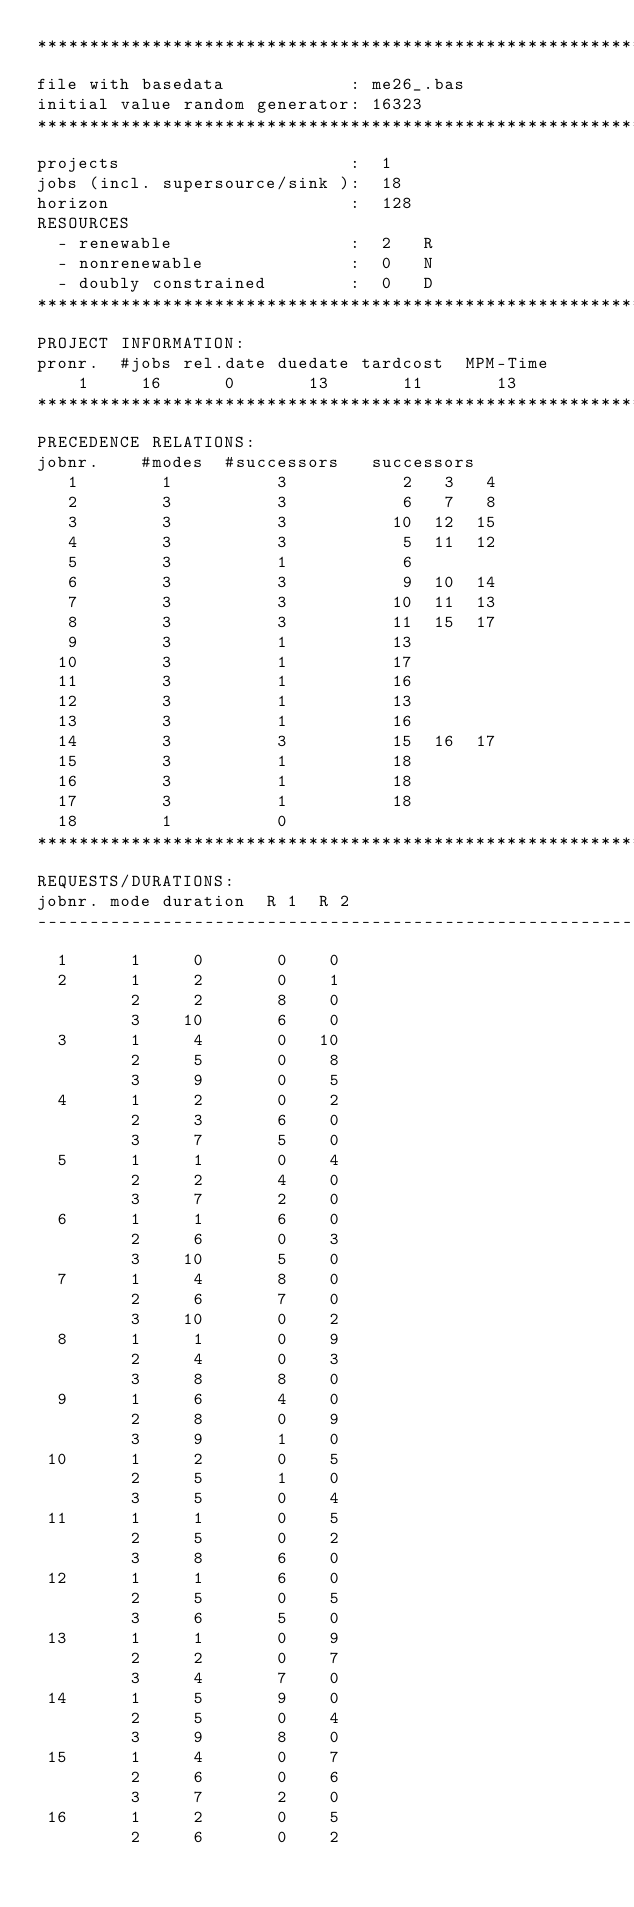<code> <loc_0><loc_0><loc_500><loc_500><_ObjectiveC_>************************************************************************
file with basedata            : me26_.bas
initial value random generator: 16323
************************************************************************
projects                      :  1
jobs (incl. supersource/sink ):  18
horizon                       :  128
RESOURCES
  - renewable                 :  2   R
  - nonrenewable              :  0   N
  - doubly constrained        :  0   D
************************************************************************
PROJECT INFORMATION:
pronr.  #jobs rel.date duedate tardcost  MPM-Time
    1     16      0       13       11       13
************************************************************************
PRECEDENCE RELATIONS:
jobnr.    #modes  #successors   successors
   1        1          3           2   3   4
   2        3          3           6   7   8
   3        3          3          10  12  15
   4        3          3           5  11  12
   5        3          1           6
   6        3          3           9  10  14
   7        3          3          10  11  13
   8        3          3          11  15  17
   9        3          1          13
  10        3          1          17
  11        3          1          16
  12        3          1          13
  13        3          1          16
  14        3          3          15  16  17
  15        3          1          18
  16        3          1          18
  17        3          1          18
  18        1          0        
************************************************************************
REQUESTS/DURATIONS:
jobnr. mode duration  R 1  R 2
------------------------------------------------------------------------
  1      1     0       0    0
  2      1     2       0    1
         2     2       8    0
         3    10       6    0
  3      1     4       0   10
         2     5       0    8
         3     9       0    5
  4      1     2       0    2
         2     3       6    0
         3     7       5    0
  5      1     1       0    4
         2     2       4    0
         3     7       2    0
  6      1     1       6    0
         2     6       0    3
         3    10       5    0
  7      1     4       8    0
         2     6       7    0
         3    10       0    2
  8      1     1       0    9
         2     4       0    3
         3     8       8    0
  9      1     6       4    0
         2     8       0    9
         3     9       1    0
 10      1     2       0    5
         2     5       1    0
         3     5       0    4
 11      1     1       0    5
         2     5       0    2
         3     8       6    0
 12      1     1       6    0
         2     5       0    5
         3     6       5    0
 13      1     1       0    9
         2     2       0    7
         3     4       7    0
 14      1     5       9    0
         2     5       0    4
         3     9       8    0
 15      1     4       0    7
         2     6       0    6
         3     7       2    0
 16      1     2       0    5
         2     6       0    2</code> 